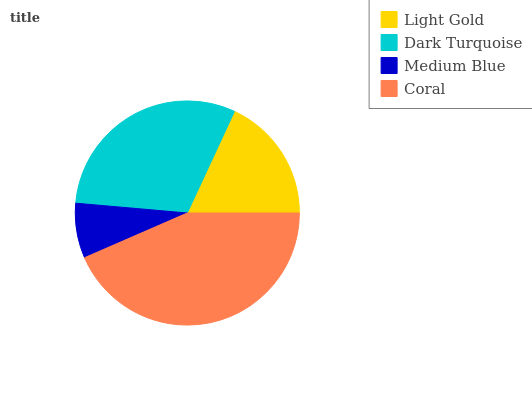Is Medium Blue the minimum?
Answer yes or no. Yes. Is Coral the maximum?
Answer yes or no. Yes. Is Dark Turquoise the minimum?
Answer yes or no. No. Is Dark Turquoise the maximum?
Answer yes or no. No. Is Dark Turquoise greater than Light Gold?
Answer yes or no. Yes. Is Light Gold less than Dark Turquoise?
Answer yes or no. Yes. Is Light Gold greater than Dark Turquoise?
Answer yes or no. No. Is Dark Turquoise less than Light Gold?
Answer yes or no. No. Is Dark Turquoise the high median?
Answer yes or no. Yes. Is Light Gold the low median?
Answer yes or no. Yes. Is Coral the high median?
Answer yes or no. No. Is Medium Blue the low median?
Answer yes or no. No. 